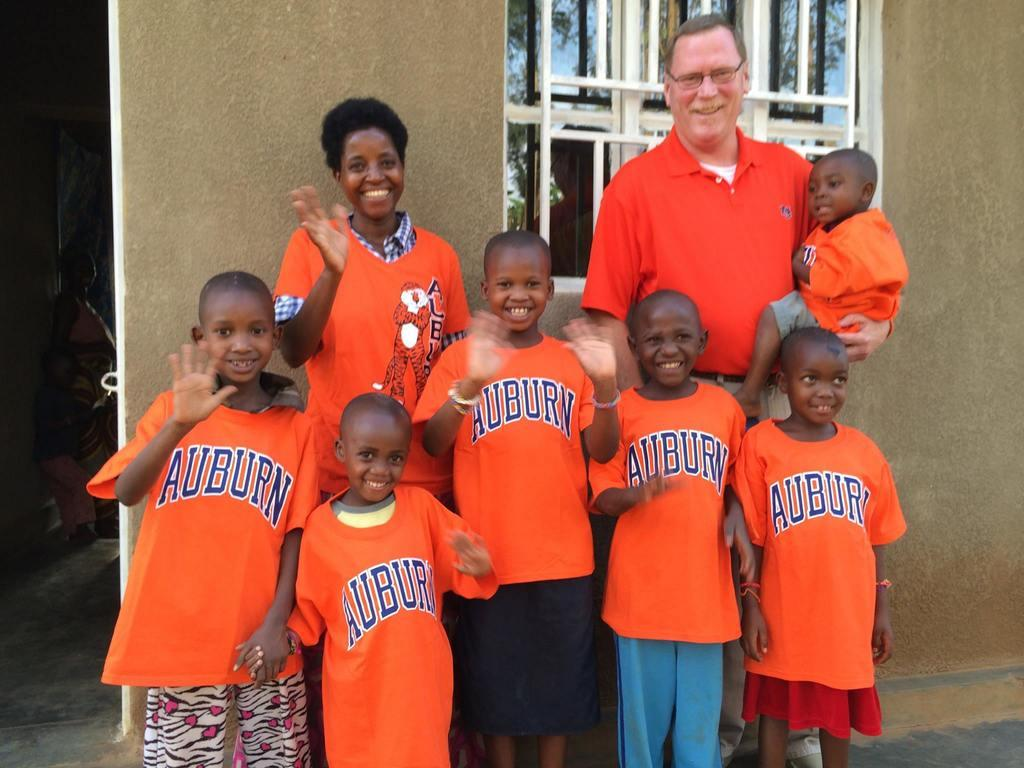<image>
Create a compact narrative representing the image presented. Various kids and adults wear shirts that say Auburn 